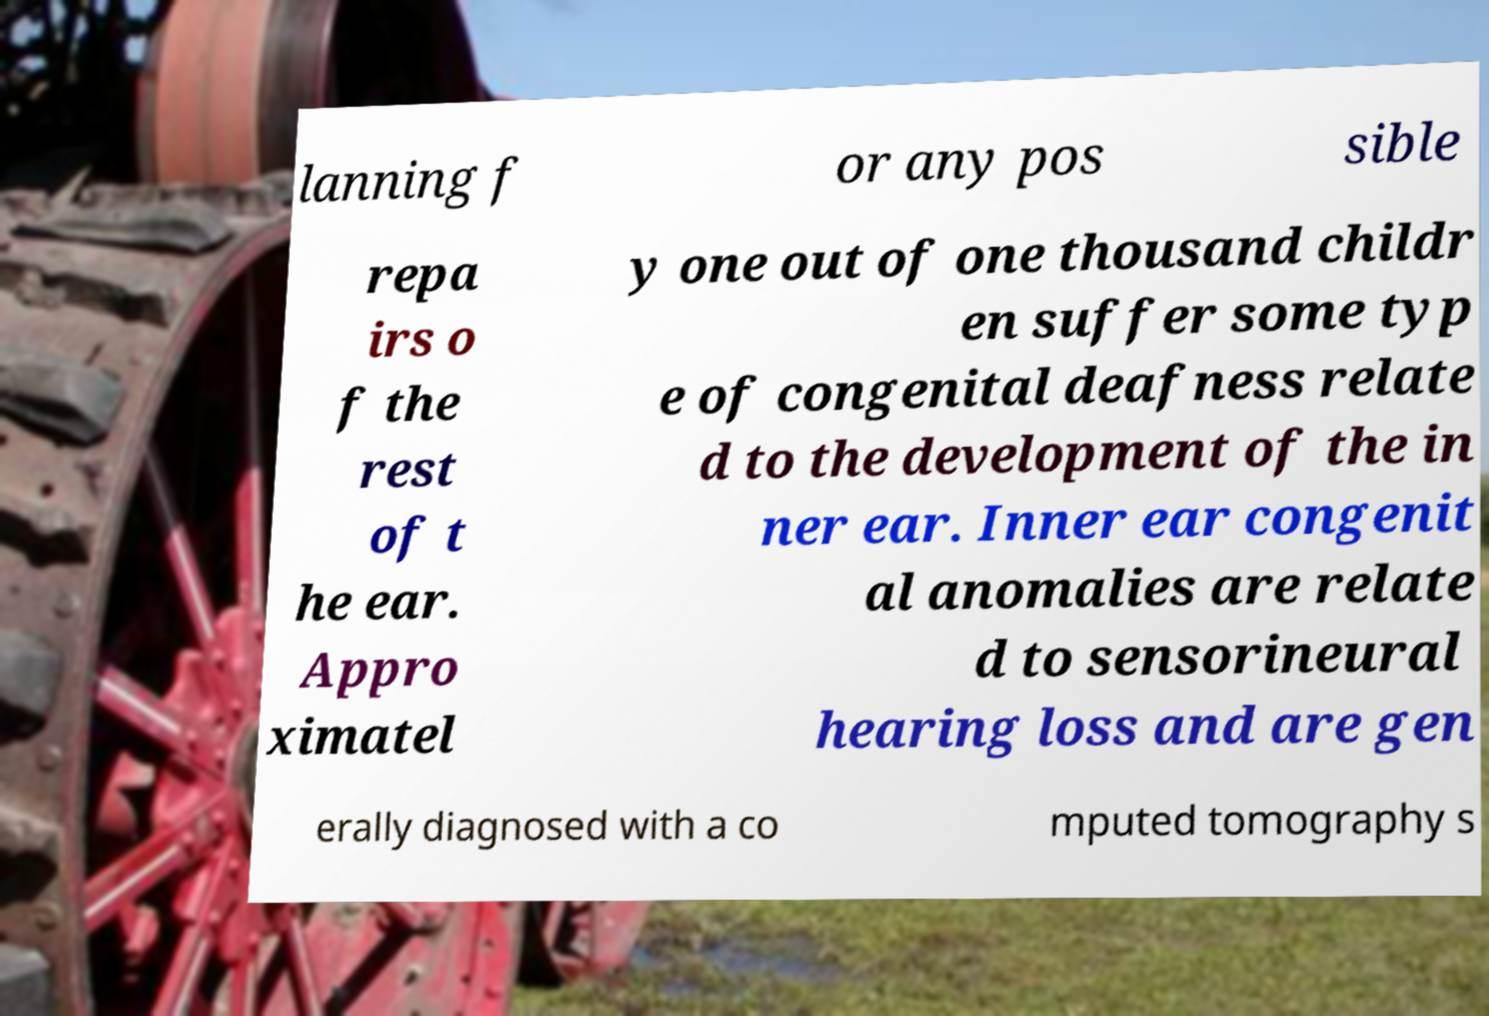Can you read and provide the text displayed in the image?This photo seems to have some interesting text. Can you extract and type it out for me? lanning f or any pos sible repa irs o f the rest of t he ear. Appro ximatel y one out of one thousand childr en suffer some typ e of congenital deafness relate d to the development of the in ner ear. Inner ear congenit al anomalies are relate d to sensorineural hearing loss and are gen erally diagnosed with a co mputed tomography s 